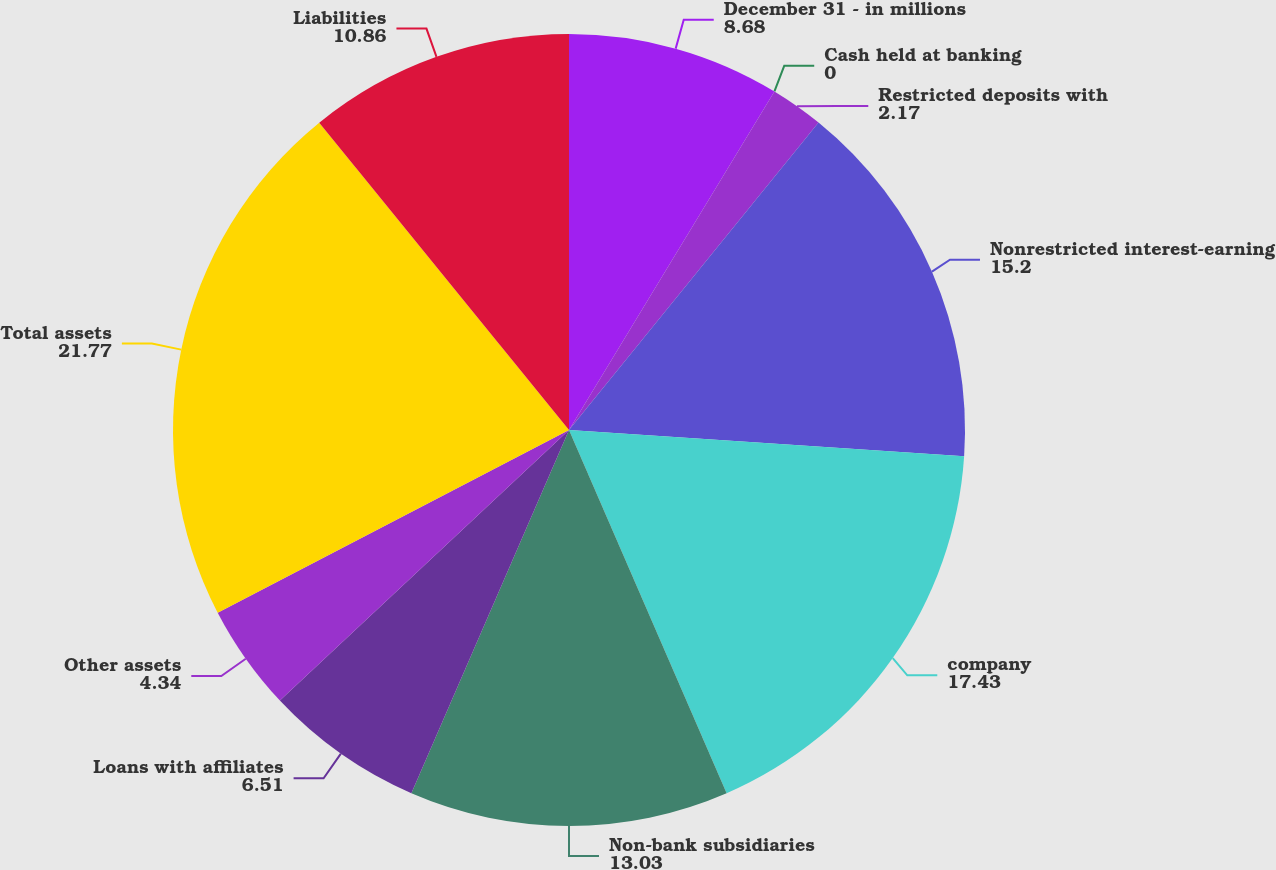<chart> <loc_0><loc_0><loc_500><loc_500><pie_chart><fcel>December 31 - in millions<fcel>Cash held at banking<fcel>Restricted deposits with<fcel>Nonrestricted interest-earning<fcel>company<fcel>Non-bank subsidiaries<fcel>Loans with affiliates<fcel>Other assets<fcel>Total assets<fcel>Liabilities<nl><fcel>8.68%<fcel>0.0%<fcel>2.17%<fcel>15.2%<fcel>17.43%<fcel>13.03%<fcel>6.51%<fcel>4.34%<fcel>21.77%<fcel>10.86%<nl></chart> 